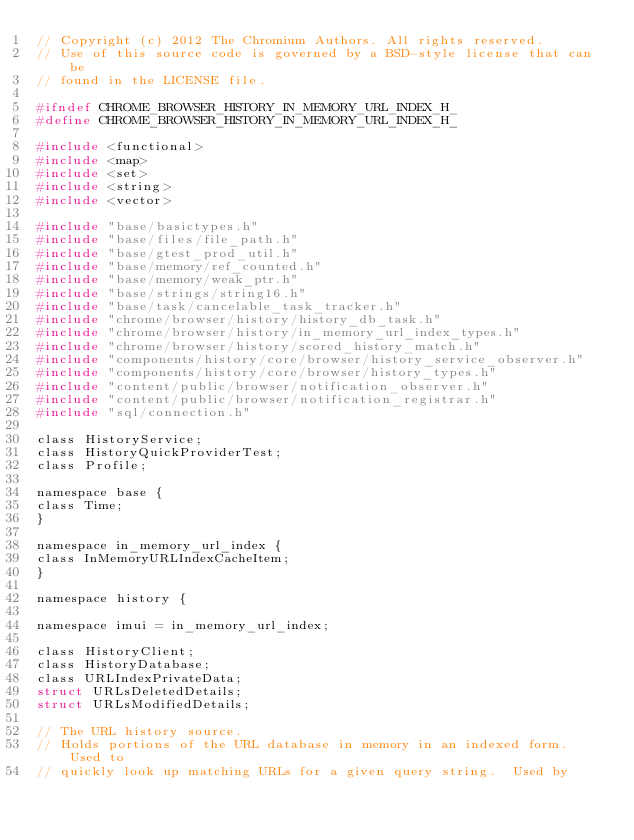<code> <loc_0><loc_0><loc_500><loc_500><_C_>// Copyright (c) 2012 The Chromium Authors. All rights reserved.
// Use of this source code is governed by a BSD-style license that can be
// found in the LICENSE file.

#ifndef CHROME_BROWSER_HISTORY_IN_MEMORY_URL_INDEX_H_
#define CHROME_BROWSER_HISTORY_IN_MEMORY_URL_INDEX_H_

#include <functional>
#include <map>
#include <set>
#include <string>
#include <vector>

#include "base/basictypes.h"
#include "base/files/file_path.h"
#include "base/gtest_prod_util.h"
#include "base/memory/ref_counted.h"
#include "base/memory/weak_ptr.h"
#include "base/strings/string16.h"
#include "base/task/cancelable_task_tracker.h"
#include "chrome/browser/history/history_db_task.h"
#include "chrome/browser/history/in_memory_url_index_types.h"
#include "chrome/browser/history/scored_history_match.h"
#include "components/history/core/browser/history_service_observer.h"
#include "components/history/core/browser/history_types.h"
#include "content/public/browser/notification_observer.h"
#include "content/public/browser/notification_registrar.h"
#include "sql/connection.h"

class HistoryService;
class HistoryQuickProviderTest;
class Profile;

namespace base {
class Time;
}

namespace in_memory_url_index {
class InMemoryURLIndexCacheItem;
}

namespace history {

namespace imui = in_memory_url_index;

class HistoryClient;
class HistoryDatabase;
class URLIndexPrivateData;
struct URLsDeletedDetails;
struct URLsModifiedDetails;

// The URL history source.
// Holds portions of the URL database in memory in an indexed form.  Used to
// quickly look up matching URLs for a given query string.  Used by</code> 